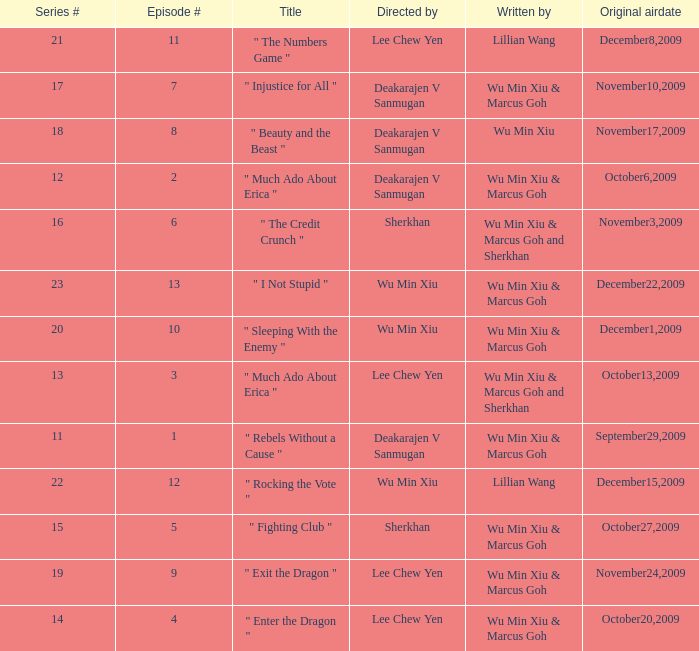What is the episode number for series 17? 7.0. 